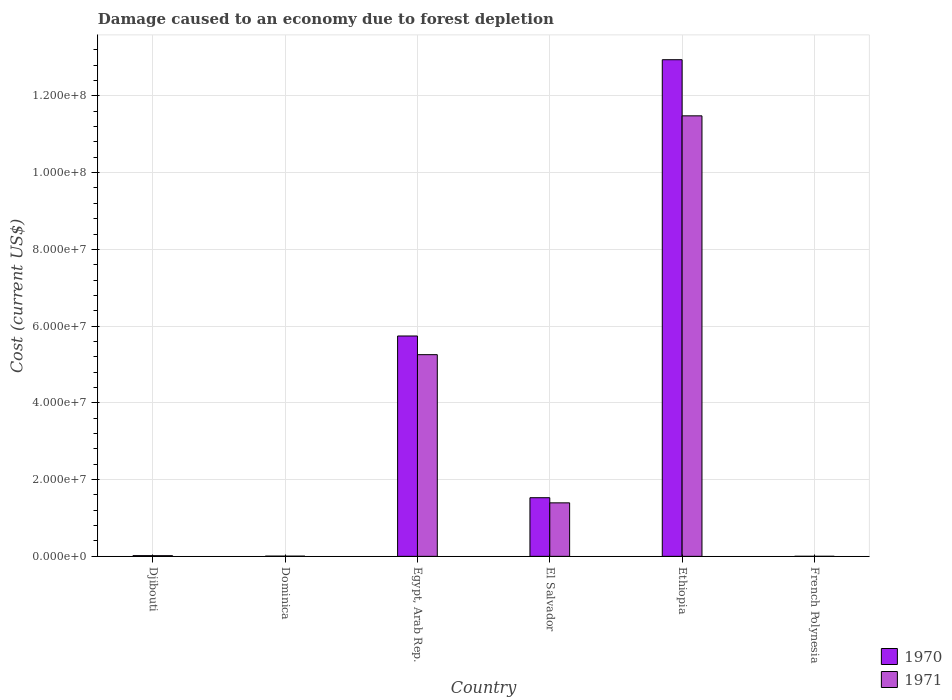How many groups of bars are there?
Give a very brief answer. 6. How many bars are there on the 3rd tick from the left?
Your response must be concise. 2. How many bars are there on the 4th tick from the right?
Your answer should be compact. 2. What is the label of the 3rd group of bars from the left?
Your answer should be very brief. Egypt, Arab Rep. What is the cost of damage caused due to forest depletion in 1970 in Dominica?
Make the answer very short. 5.98e+04. Across all countries, what is the maximum cost of damage caused due to forest depletion in 1970?
Provide a succinct answer. 1.29e+08. Across all countries, what is the minimum cost of damage caused due to forest depletion in 1971?
Make the answer very short. 9061.15. In which country was the cost of damage caused due to forest depletion in 1970 maximum?
Provide a succinct answer. Ethiopia. In which country was the cost of damage caused due to forest depletion in 1970 minimum?
Keep it short and to the point. French Polynesia. What is the total cost of damage caused due to forest depletion in 1971 in the graph?
Your answer should be compact. 1.82e+08. What is the difference between the cost of damage caused due to forest depletion in 1971 in Djibouti and that in Dominica?
Offer a terse response. 1.22e+05. What is the difference between the cost of damage caused due to forest depletion in 1970 in Ethiopia and the cost of damage caused due to forest depletion in 1971 in Egypt, Arab Rep.?
Offer a terse response. 7.69e+07. What is the average cost of damage caused due to forest depletion in 1971 per country?
Your response must be concise. 3.03e+07. What is the difference between the cost of damage caused due to forest depletion of/in 1971 and cost of damage caused due to forest depletion of/in 1970 in Dominica?
Make the answer very short. -8949.07. In how many countries, is the cost of damage caused due to forest depletion in 1971 greater than 116000000 US$?
Your answer should be very brief. 0. What is the ratio of the cost of damage caused due to forest depletion in 1970 in Ethiopia to that in French Polynesia?
Offer a terse response. 1.10e+04. What is the difference between the highest and the second highest cost of damage caused due to forest depletion in 1970?
Your answer should be compact. 4.21e+07. What is the difference between the highest and the lowest cost of damage caused due to forest depletion in 1971?
Your response must be concise. 1.15e+08. In how many countries, is the cost of damage caused due to forest depletion in 1970 greater than the average cost of damage caused due to forest depletion in 1970 taken over all countries?
Your answer should be very brief. 2. Are all the bars in the graph horizontal?
Give a very brief answer. No. What is the difference between two consecutive major ticks on the Y-axis?
Make the answer very short. 2.00e+07. Are the values on the major ticks of Y-axis written in scientific E-notation?
Give a very brief answer. Yes. Where does the legend appear in the graph?
Your answer should be very brief. Bottom right. How are the legend labels stacked?
Offer a very short reply. Vertical. What is the title of the graph?
Keep it short and to the point. Damage caused to an economy due to forest depletion. What is the label or title of the Y-axis?
Give a very brief answer. Cost (current US$). What is the Cost (current US$) of 1970 in Djibouti?
Provide a short and direct response. 1.85e+05. What is the Cost (current US$) in 1971 in Djibouti?
Offer a very short reply. 1.73e+05. What is the Cost (current US$) of 1970 in Dominica?
Offer a very short reply. 5.98e+04. What is the Cost (current US$) of 1971 in Dominica?
Your answer should be very brief. 5.09e+04. What is the Cost (current US$) of 1970 in Egypt, Arab Rep.?
Offer a terse response. 5.74e+07. What is the Cost (current US$) of 1971 in Egypt, Arab Rep.?
Offer a terse response. 5.26e+07. What is the Cost (current US$) in 1970 in El Salvador?
Offer a terse response. 1.53e+07. What is the Cost (current US$) in 1971 in El Salvador?
Give a very brief answer. 1.39e+07. What is the Cost (current US$) in 1970 in Ethiopia?
Give a very brief answer. 1.29e+08. What is the Cost (current US$) in 1971 in Ethiopia?
Keep it short and to the point. 1.15e+08. What is the Cost (current US$) of 1970 in French Polynesia?
Offer a terse response. 1.18e+04. What is the Cost (current US$) of 1971 in French Polynesia?
Provide a short and direct response. 9061.15. Across all countries, what is the maximum Cost (current US$) of 1970?
Your response must be concise. 1.29e+08. Across all countries, what is the maximum Cost (current US$) of 1971?
Give a very brief answer. 1.15e+08. Across all countries, what is the minimum Cost (current US$) of 1970?
Make the answer very short. 1.18e+04. Across all countries, what is the minimum Cost (current US$) of 1971?
Offer a terse response. 9061.15. What is the total Cost (current US$) in 1970 in the graph?
Your answer should be compact. 2.02e+08. What is the total Cost (current US$) of 1971 in the graph?
Your answer should be very brief. 1.82e+08. What is the difference between the Cost (current US$) of 1970 in Djibouti and that in Dominica?
Your answer should be very brief. 1.25e+05. What is the difference between the Cost (current US$) of 1971 in Djibouti and that in Dominica?
Your answer should be very brief. 1.22e+05. What is the difference between the Cost (current US$) of 1970 in Djibouti and that in Egypt, Arab Rep.?
Keep it short and to the point. -5.72e+07. What is the difference between the Cost (current US$) of 1971 in Djibouti and that in Egypt, Arab Rep.?
Provide a succinct answer. -5.24e+07. What is the difference between the Cost (current US$) in 1970 in Djibouti and that in El Salvador?
Make the answer very short. -1.51e+07. What is the difference between the Cost (current US$) of 1971 in Djibouti and that in El Salvador?
Your response must be concise. -1.38e+07. What is the difference between the Cost (current US$) of 1970 in Djibouti and that in Ethiopia?
Offer a terse response. -1.29e+08. What is the difference between the Cost (current US$) in 1971 in Djibouti and that in Ethiopia?
Provide a short and direct response. -1.15e+08. What is the difference between the Cost (current US$) in 1970 in Djibouti and that in French Polynesia?
Give a very brief answer. 1.73e+05. What is the difference between the Cost (current US$) in 1971 in Djibouti and that in French Polynesia?
Your answer should be compact. 1.64e+05. What is the difference between the Cost (current US$) in 1970 in Dominica and that in Egypt, Arab Rep.?
Make the answer very short. -5.74e+07. What is the difference between the Cost (current US$) of 1971 in Dominica and that in Egypt, Arab Rep.?
Make the answer very short. -5.25e+07. What is the difference between the Cost (current US$) of 1970 in Dominica and that in El Salvador?
Your answer should be very brief. -1.52e+07. What is the difference between the Cost (current US$) of 1971 in Dominica and that in El Salvador?
Make the answer very short. -1.39e+07. What is the difference between the Cost (current US$) of 1970 in Dominica and that in Ethiopia?
Your response must be concise. -1.29e+08. What is the difference between the Cost (current US$) of 1971 in Dominica and that in Ethiopia?
Your answer should be very brief. -1.15e+08. What is the difference between the Cost (current US$) in 1970 in Dominica and that in French Polynesia?
Your answer should be compact. 4.81e+04. What is the difference between the Cost (current US$) in 1971 in Dominica and that in French Polynesia?
Offer a terse response. 4.18e+04. What is the difference between the Cost (current US$) of 1970 in Egypt, Arab Rep. and that in El Salvador?
Offer a terse response. 4.21e+07. What is the difference between the Cost (current US$) in 1971 in Egypt, Arab Rep. and that in El Salvador?
Your answer should be compact. 3.86e+07. What is the difference between the Cost (current US$) in 1970 in Egypt, Arab Rep. and that in Ethiopia?
Provide a short and direct response. -7.20e+07. What is the difference between the Cost (current US$) of 1971 in Egypt, Arab Rep. and that in Ethiopia?
Provide a short and direct response. -6.22e+07. What is the difference between the Cost (current US$) in 1970 in Egypt, Arab Rep. and that in French Polynesia?
Your answer should be very brief. 5.74e+07. What is the difference between the Cost (current US$) in 1971 in Egypt, Arab Rep. and that in French Polynesia?
Provide a succinct answer. 5.26e+07. What is the difference between the Cost (current US$) in 1970 in El Salvador and that in Ethiopia?
Make the answer very short. -1.14e+08. What is the difference between the Cost (current US$) in 1971 in El Salvador and that in Ethiopia?
Your answer should be compact. -1.01e+08. What is the difference between the Cost (current US$) of 1970 in El Salvador and that in French Polynesia?
Ensure brevity in your answer.  1.53e+07. What is the difference between the Cost (current US$) in 1971 in El Salvador and that in French Polynesia?
Make the answer very short. 1.39e+07. What is the difference between the Cost (current US$) of 1970 in Ethiopia and that in French Polynesia?
Your response must be concise. 1.29e+08. What is the difference between the Cost (current US$) in 1971 in Ethiopia and that in French Polynesia?
Make the answer very short. 1.15e+08. What is the difference between the Cost (current US$) in 1970 in Djibouti and the Cost (current US$) in 1971 in Dominica?
Your answer should be very brief. 1.34e+05. What is the difference between the Cost (current US$) in 1970 in Djibouti and the Cost (current US$) in 1971 in Egypt, Arab Rep.?
Provide a short and direct response. -5.24e+07. What is the difference between the Cost (current US$) of 1970 in Djibouti and the Cost (current US$) of 1971 in El Salvador?
Offer a very short reply. -1.38e+07. What is the difference between the Cost (current US$) of 1970 in Djibouti and the Cost (current US$) of 1971 in Ethiopia?
Give a very brief answer. -1.15e+08. What is the difference between the Cost (current US$) in 1970 in Djibouti and the Cost (current US$) in 1971 in French Polynesia?
Your answer should be compact. 1.76e+05. What is the difference between the Cost (current US$) in 1970 in Dominica and the Cost (current US$) in 1971 in Egypt, Arab Rep.?
Your response must be concise. -5.25e+07. What is the difference between the Cost (current US$) of 1970 in Dominica and the Cost (current US$) of 1971 in El Salvador?
Offer a very short reply. -1.39e+07. What is the difference between the Cost (current US$) of 1970 in Dominica and the Cost (current US$) of 1971 in Ethiopia?
Provide a short and direct response. -1.15e+08. What is the difference between the Cost (current US$) in 1970 in Dominica and the Cost (current US$) in 1971 in French Polynesia?
Your answer should be compact. 5.08e+04. What is the difference between the Cost (current US$) in 1970 in Egypt, Arab Rep. and the Cost (current US$) in 1971 in El Salvador?
Provide a short and direct response. 4.35e+07. What is the difference between the Cost (current US$) of 1970 in Egypt, Arab Rep. and the Cost (current US$) of 1971 in Ethiopia?
Provide a short and direct response. -5.74e+07. What is the difference between the Cost (current US$) in 1970 in Egypt, Arab Rep. and the Cost (current US$) in 1971 in French Polynesia?
Offer a terse response. 5.74e+07. What is the difference between the Cost (current US$) of 1970 in El Salvador and the Cost (current US$) of 1971 in Ethiopia?
Provide a succinct answer. -9.95e+07. What is the difference between the Cost (current US$) in 1970 in El Salvador and the Cost (current US$) in 1971 in French Polynesia?
Your answer should be very brief. 1.53e+07. What is the difference between the Cost (current US$) of 1970 in Ethiopia and the Cost (current US$) of 1971 in French Polynesia?
Offer a very short reply. 1.29e+08. What is the average Cost (current US$) in 1970 per country?
Your answer should be very brief. 3.37e+07. What is the average Cost (current US$) in 1971 per country?
Provide a short and direct response. 3.03e+07. What is the difference between the Cost (current US$) of 1970 and Cost (current US$) of 1971 in Djibouti?
Your response must be concise. 1.14e+04. What is the difference between the Cost (current US$) of 1970 and Cost (current US$) of 1971 in Dominica?
Your answer should be compact. 8949.07. What is the difference between the Cost (current US$) in 1970 and Cost (current US$) in 1971 in Egypt, Arab Rep.?
Your response must be concise. 4.87e+06. What is the difference between the Cost (current US$) of 1970 and Cost (current US$) of 1971 in El Salvador?
Give a very brief answer. 1.34e+06. What is the difference between the Cost (current US$) of 1970 and Cost (current US$) of 1971 in Ethiopia?
Offer a very short reply. 1.46e+07. What is the difference between the Cost (current US$) of 1970 and Cost (current US$) of 1971 in French Polynesia?
Offer a very short reply. 2690.05. What is the ratio of the Cost (current US$) of 1970 in Djibouti to that in Dominica?
Ensure brevity in your answer.  3.09. What is the ratio of the Cost (current US$) of 1971 in Djibouti to that in Dominica?
Offer a terse response. 3.41. What is the ratio of the Cost (current US$) in 1970 in Djibouti to that in Egypt, Arab Rep.?
Provide a succinct answer. 0. What is the ratio of the Cost (current US$) in 1971 in Djibouti to that in Egypt, Arab Rep.?
Your answer should be very brief. 0. What is the ratio of the Cost (current US$) in 1970 in Djibouti to that in El Salvador?
Keep it short and to the point. 0.01. What is the ratio of the Cost (current US$) in 1971 in Djibouti to that in El Salvador?
Offer a very short reply. 0.01. What is the ratio of the Cost (current US$) of 1970 in Djibouti to that in Ethiopia?
Your answer should be very brief. 0. What is the ratio of the Cost (current US$) of 1971 in Djibouti to that in Ethiopia?
Your response must be concise. 0. What is the ratio of the Cost (current US$) of 1970 in Djibouti to that in French Polynesia?
Provide a short and direct response. 15.72. What is the ratio of the Cost (current US$) in 1971 in Djibouti to that in French Polynesia?
Your response must be concise. 19.13. What is the ratio of the Cost (current US$) in 1970 in Dominica to that in El Salvador?
Give a very brief answer. 0. What is the ratio of the Cost (current US$) in 1971 in Dominica to that in El Salvador?
Make the answer very short. 0. What is the ratio of the Cost (current US$) of 1970 in Dominica to that in French Polynesia?
Your response must be concise. 5.09. What is the ratio of the Cost (current US$) in 1971 in Dominica to that in French Polynesia?
Give a very brief answer. 5.61. What is the ratio of the Cost (current US$) of 1970 in Egypt, Arab Rep. to that in El Salvador?
Offer a very short reply. 3.76. What is the ratio of the Cost (current US$) of 1971 in Egypt, Arab Rep. to that in El Salvador?
Your response must be concise. 3.77. What is the ratio of the Cost (current US$) in 1970 in Egypt, Arab Rep. to that in Ethiopia?
Give a very brief answer. 0.44. What is the ratio of the Cost (current US$) in 1971 in Egypt, Arab Rep. to that in Ethiopia?
Give a very brief answer. 0.46. What is the ratio of the Cost (current US$) in 1970 in Egypt, Arab Rep. to that in French Polynesia?
Provide a succinct answer. 4887.16. What is the ratio of the Cost (current US$) of 1971 in Egypt, Arab Rep. to that in French Polynesia?
Your answer should be very brief. 5800.64. What is the ratio of the Cost (current US$) in 1970 in El Salvador to that in Ethiopia?
Keep it short and to the point. 0.12. What is the ratio of the Cost (current US$) in 1971 in El Salvador to that in Ethiopia?
Give a very brief answer. 0.12. What is the ratio of the Cost (current US$) in 1970 in El Salvador to that in French Polynesia?
Provide a succinct answer. 1300.42. What is the ratio of the Cost (current US$) in 1971 in El Salvador to that in French Polynesia?
Make the answer very short. 1538.5. What is the ratio of the Cost (current US$) of 1970 in Ethiopia to that in French Polynesia?
Offer a terse response. 1.10e+04. What is the ratio of the Cost (current US$) of 1971 in Ethiopia to that in French Polynesia?
Provide a short and direct response. 1.27e+04. What is the difference between the highest and the second highest Cost (current US$) of 1970?
Ensure brevity in your answer.  7.20e+07. What is the difference between the highest and the second highest Cost (current US$) of 1971?
Keep it short and to the point. 6.22e+07. What is the difference between the highest and the lowest Cost (current US$) in 1970?
Keep it short and to the point. 1.29e+08. What is the difference between the highest and the lowest Cost (current US$) of 1971?
Offer a terse response. 1.15e+08. 